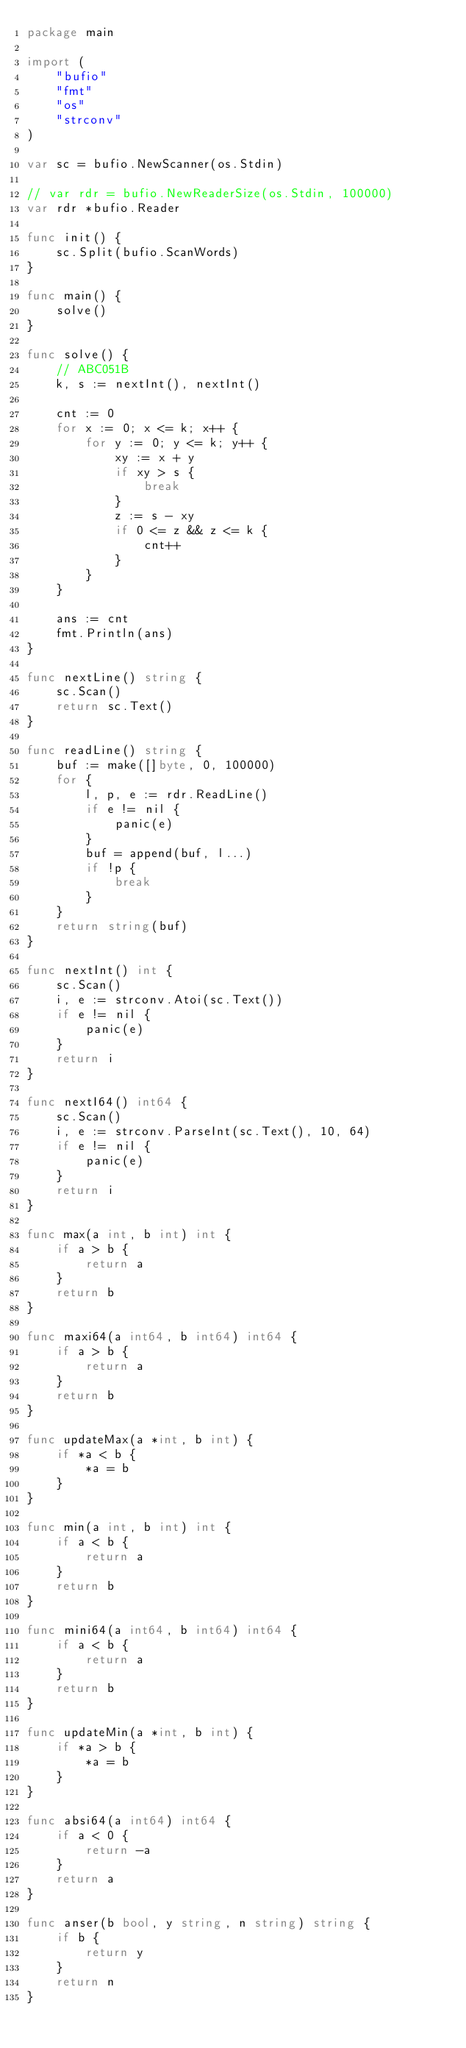<code> <loc_0><loc_0><loc_500><loc_500><_Go_>package main

import (
	"bufio"
	"fmt"
	"os"
	"strconv"
)

var sc = bufio.NewScanner(os.Stdin)

// var rdr = bufio.NewReaderSize(os.Stdin, 100000)
var rdr *bufio.Reader

func init() {
	sc.Split(bufio.ScanWords)
}

func main() {
	solve()
}

func solve() {
	// ABC051B
	k, s := nextInt(), nextInt()

	cnt := 0
	for x := 0; x <= k; x++ {
		for y := 0; y <= k; y++ {
			xy := x + y
			if xy > s {
				break
			}
			z := s - xy
			if 0 <= z && z <= k {
				cnt++
			}
		}
	}

	ans := cnt
	fmt.Println(ans)
}

func nextLine() string {
	sc.Scan()
	return sc.Text()
}

func readLine() string {
	buf := make([]byte, 0, 100000)
	for {
		l, p, e := rdr.ReadLine()
		if e != nil {
			panic(e)
		}
		buf = append(buf, l...)
		if !p {
			break
		}
	}
	return string(buf)
}

func nextInt() int {
	sc.Scan()
	i, e := strconv.Atoi(sc.Text())
	if e != nil {
		panic(e)
	}
	return i
}

func nextI64() int64 {
	sc.Scan()
	i, e := strconv.ParseInt(sc.Text(), 10, 64)
	if e != nil {
		panic(e)
	}
	return i
}

func max(a int, b int) int {
	if a > b {
		return a
	}
	return b
}

func maxi64(a int64, b int64) int64 {
	if a > b {
		return a
	}
	return b
}

func updateMax(a *int, b int) {
	if *a < b {
		*a = b
	}
}

func min(a int, b int) int {
	if a < b {
		return a
	}
	return b
}

func mini64(a int64, b int64) int64 {
	if a < b {
		return a
	}
	return b
}

func updateMin(a *int, b int) {
	if *a > b {
		*a = b
	}
}

func absi64(a int64) int64 {
	if a < 0 {
		return -a
	}
	return a
}

func anser(b bool, y string, n string) string {
	if b {
		return y
	}
	return n
}</code> 